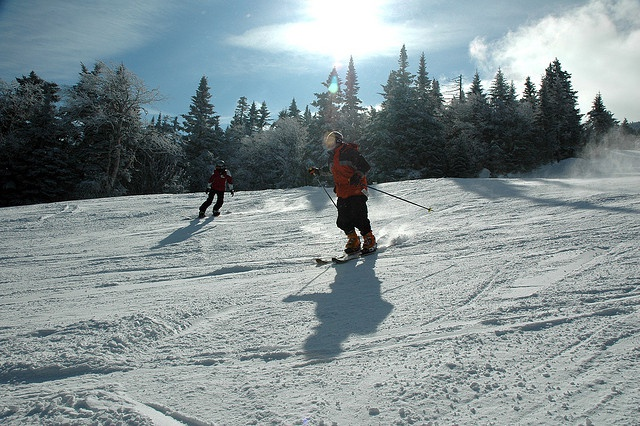Describe the objects in this image and their specific colors. I can see people in darkblue, black, maroon, and gray tones, people in darkblue, black, gray, darkgray, and purple tones, skis in darkblue, black, gray, darkgray, and lightgray tones, snowboard in darkblue, gray, black, darkgray, and lightgray tones, and skis in darkblue, black, and gray tones in this image. 